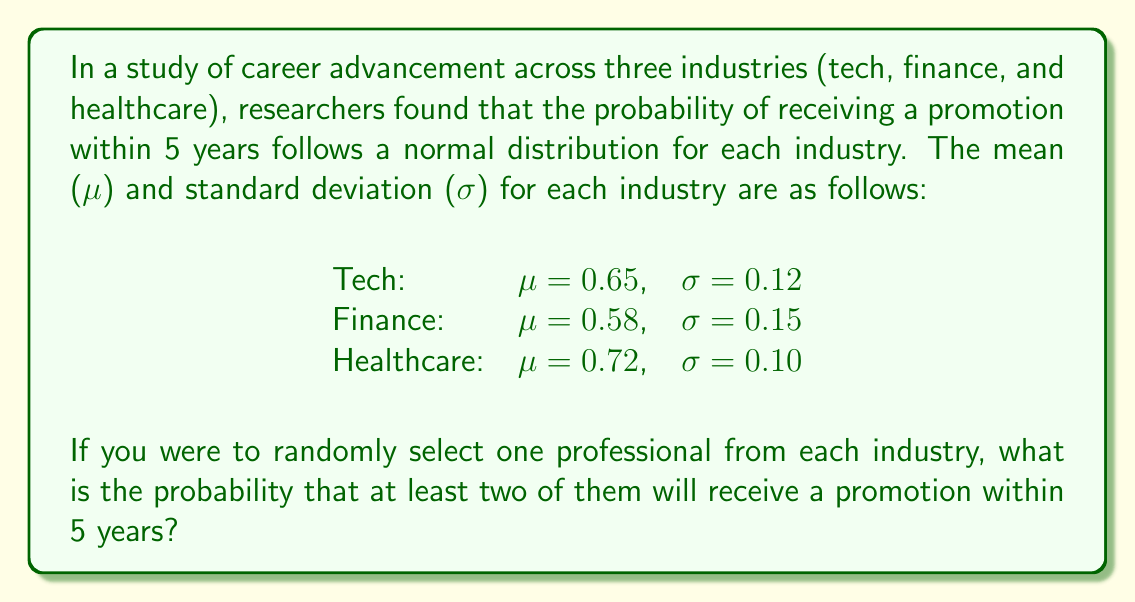Can you solve this math problem? To solve this problem, we'll use the following steps:

1) First, we need to calculate the probability of receiving a promotion for each industry using the standard normal distribution (z-score).

2) Then, we'll use the complement of the probability that none or only one professional receives a promotion.

Step 1: Calculate the probability of receiving a promotion for each industry

For each industry, we'll use the z-score formula:

$$ z = \frac{x - \mu}{\sigma} $$

Where x is the cutoff point (in this case, 5 years).

For Tech:
$$ z = \frac{5 - 0.65 \cdot 5}{0.12 \cdot 5} = \frac{2.75}{0.6} = 4.58 $$

For Finance:
$$ z = \frac{5 - 0.58 \cdot 5}{0.15 \cdot 5} = \frac{2.1}{0.75} = 2.8 $$

For Healthcare:
$$ z = \frac{5 - 0.72 \cdot 5}{0.10 \cdot 5} = \frac{1.4}{0.5} = 2.8 $$

Using a standard normal distribution table or calculator:

P(Tech) ≈ 0.9999977
P(Finance) ≈ 0.9974449
P(Healthcare) ≈ 0.9974449

Step 2: Calculate the probability of at least two professionals receiving a promotion

It's easier to calculate the complement of this probability, which is the probability that none or only one professional receives a promotion.

P(none) = (1 - 0.9999977) * (1 - 0.9974449) * (1 - 0.9974449) ≈ 1.446 × 10^-10

P(only one) = 
0.9999977 * (1 - 0.9974449) * (1 - 0.9974449) +
(1 - 0.9999977) * 0.9974449 * (1 - 0.9974449) +
(1 - 0.9999977) * (1 - 0.9974449) * 0.9974449
≈ 1.277 × 10^-6

P(none or only one) = 1.446 × 10^-10 + 1.277 × 10^-6 ≈ 1.277 × 10^-6

Therefore, the probability of at least two professionals receiving a promotion is:

P(at least two) = 1 - P(none or only one) = 1 - 1.277 × 10^-6 ≈ 0.999998723
Answer: The probability that at least two out of three randomly selected professionals (one from each industry) will receive a promotion within 5 years is approximately 0.999999, or 99.9999%. 